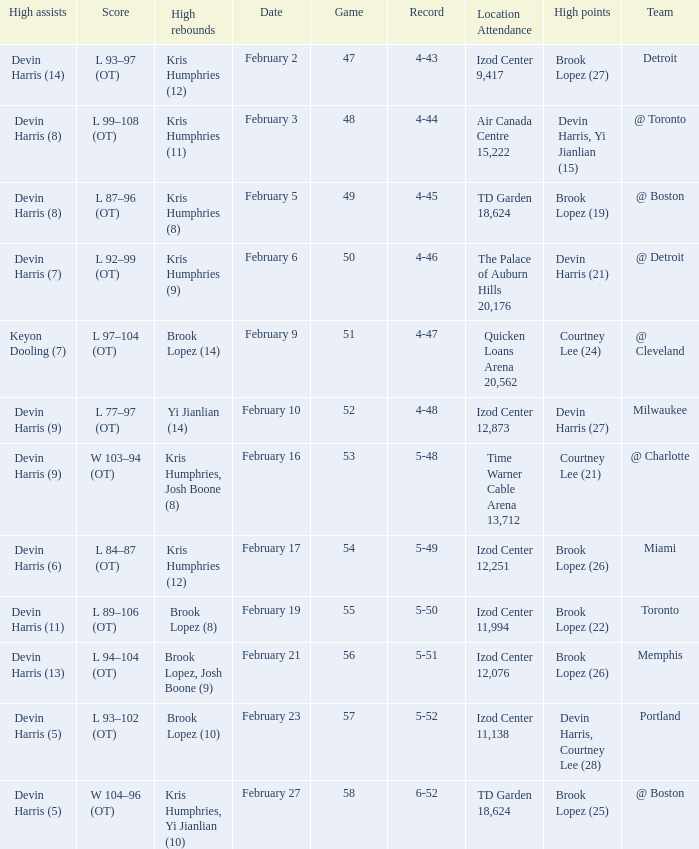What was the score of the game in which Brook Lopez (8) did the high rebounds? L 89–106 (OT). 